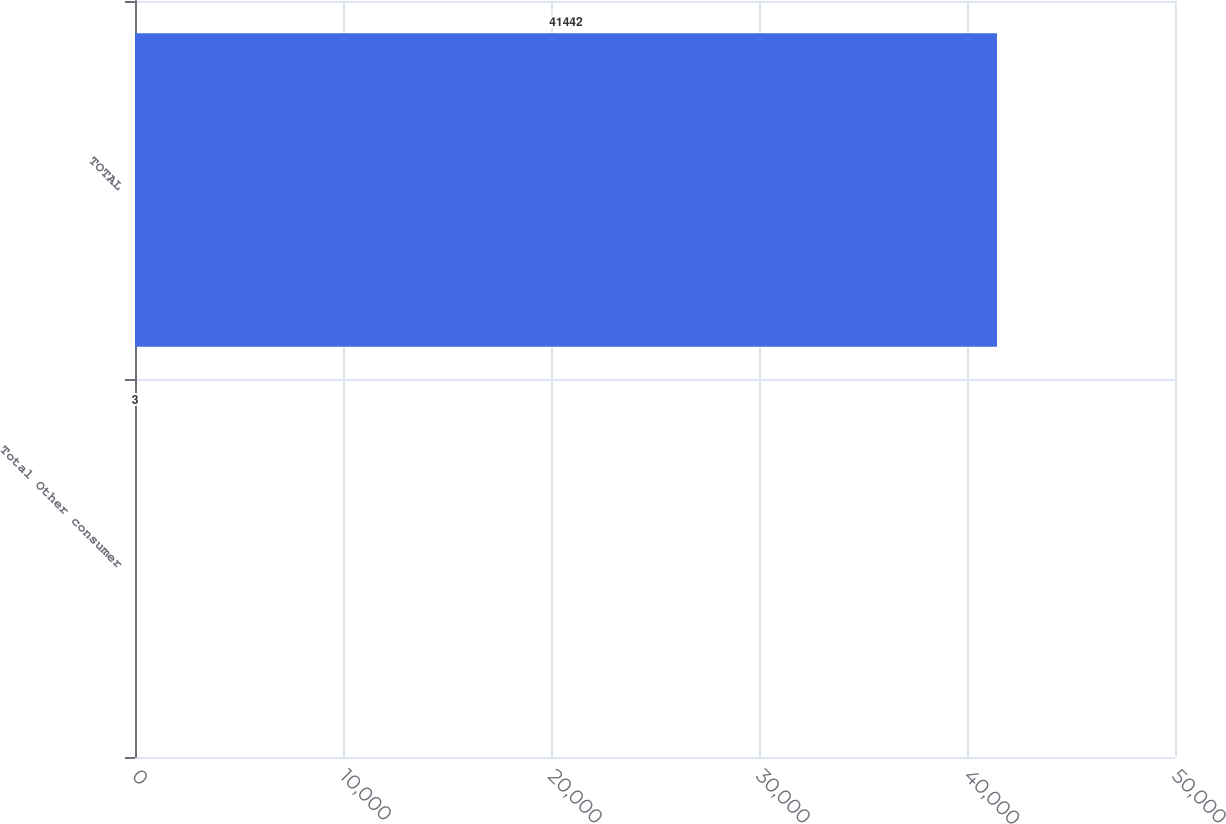Convert chart to OTSL. <chart><loc_0><loc_0><loc_500><loc_500><bar_chart><fcel>Total Other consumer<fcel>TOTAL<nl><fcel>3<fcel>41442<nl></chart> 